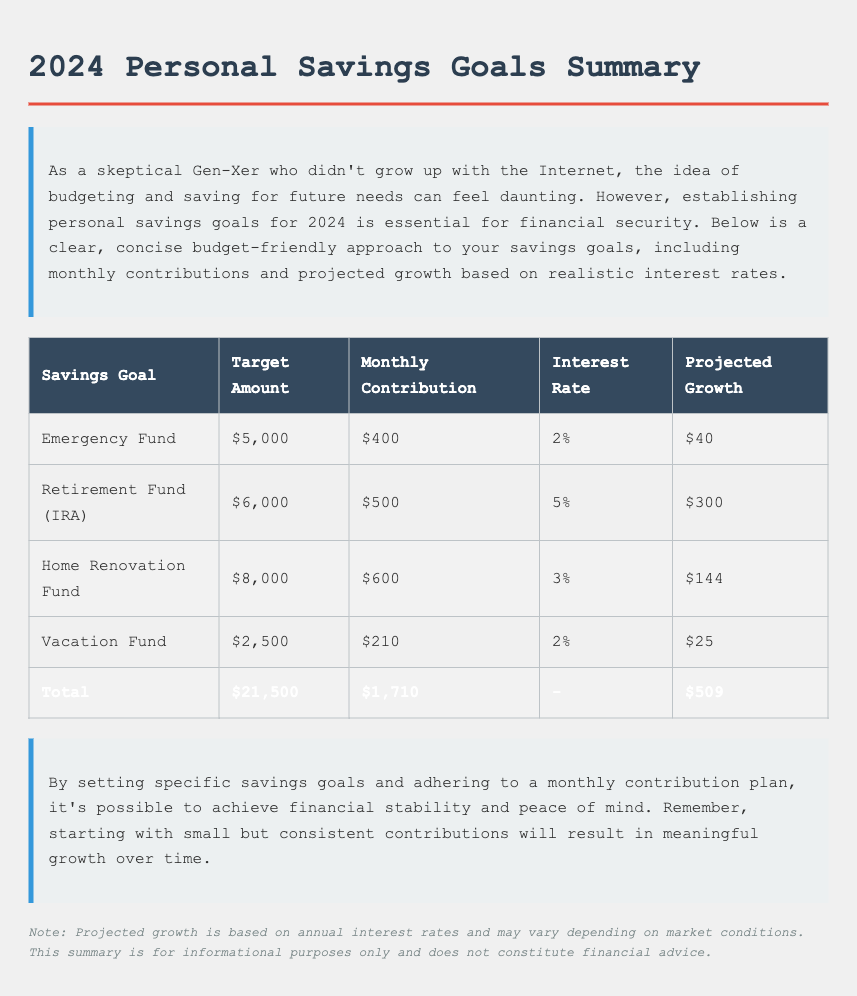What is the total target amount for all savings goals? The total target amount is calculated by summing the target amounts of each savings goal listed in the table: $5,000 + $6,000 + $8,000 + $2,500 = $21,500.
Answer: $21,500 What is the monthly contribution for the Emergency Fund? The table specifies the monthly contribution needed to reach the Emergency Fund target of $5,000, which is $400.
Answer: $400 Which savings goal has the highest target amount? The savings goal with the highest target amount in the table is the Home Renovation Fund, which has a target amount of $8,000.
Answer: Home Renovation Fund What is the projected growth for the Retirement Fund (IRA)? The projected growth for the Retirement Fund (IRA) is stated in the table as $300 based on a 5% interest rate.
Answer: $300 How much is the total monthly contribution for all savings goals? This total is found by adding the monthly contributions of each savings goal: $400 + $500 + $600 + $210 = $1,710.
Answer: $1,710 What interest rate is applied to the Vacation Fund? The table indicates that the interest rate applied to the Vacation Fund is 2%.
Answer: 2% Which savings goal requires the lowest monthly contribution? By comparing the monthly contributions of each savings goal, the Vacation Fund, with a requirement of $210, has the lowest contribution amount.
Answer: Vacation Fund What is the projected growth for the Emergency Fund? The projected growth for the Emergency Fund is stated in the table as $40, based on a 2% interest rate.
Answer: $40 